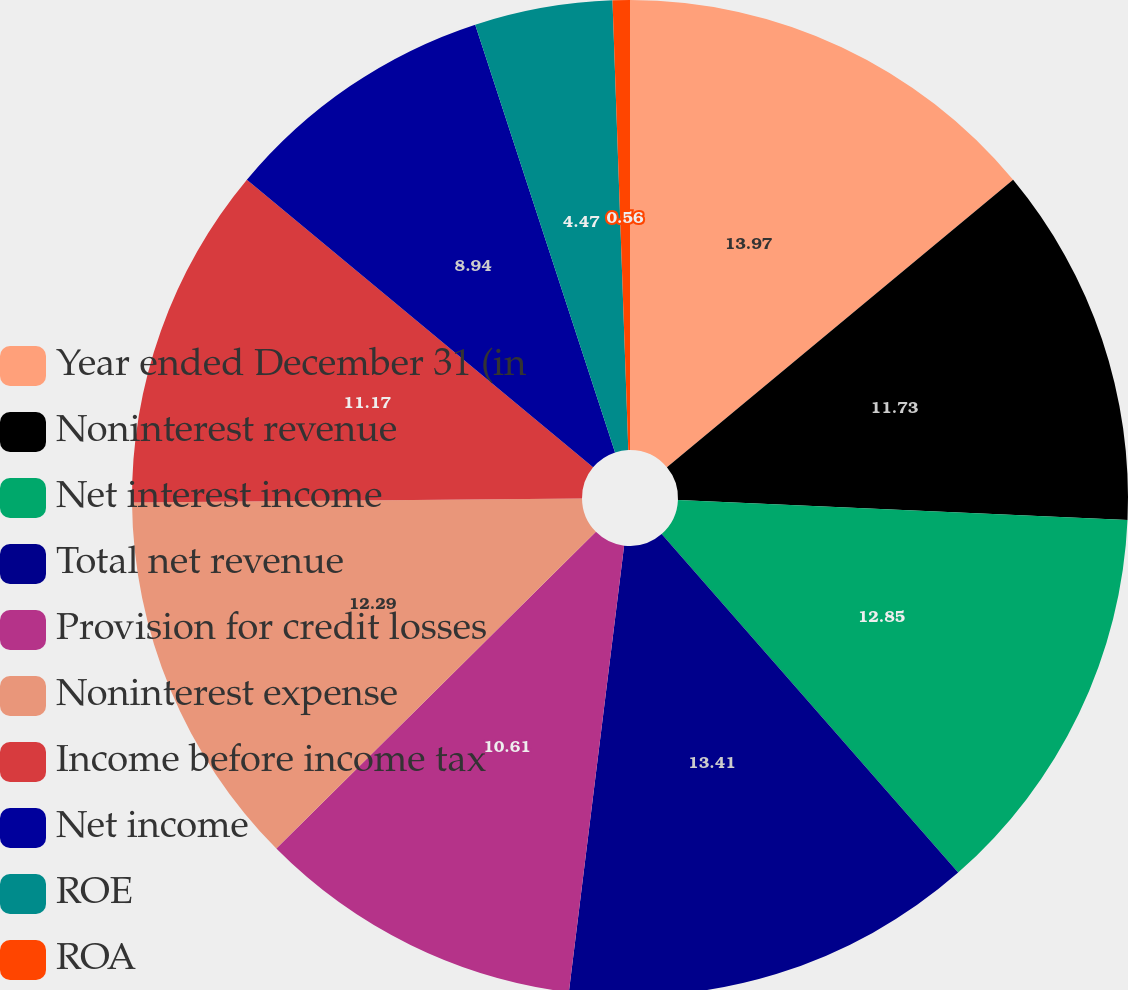<chart> <loc_0><loc_0><loc_500><loc_500><pie_chart><fcel>Year ended December 31 (in<fcel>Noninterest revenue<fcel>Net interest income<fcel>Total net revenue<fcel>Provision for credit losses<fcel>Noninterest expense<fcel>Income before income tax<fcel>Net income<fcel>ROE<fcel>ROA<nl><fcel>13.97%<fcel>11.73%<fcel>12.85%<fcel>13.41%<fcel>10.61%<fcel>12.29%<fcel>11.17%<fcel>8.94%<fcel>4.47%<fcel>0.56%<nl></chart> 